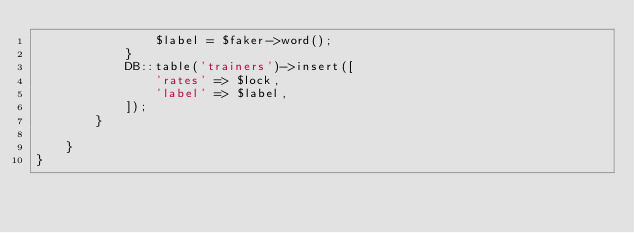Convert code to text. <code><loc_0><loc_0><loc_500><loc_500><_PHP_>                $label = $faker->word();
            }
            DB::table('trainers')->insert([
                'rates' => $lock,
                'label' => $label,
            ]);
        }
        
    }
}
</code> 